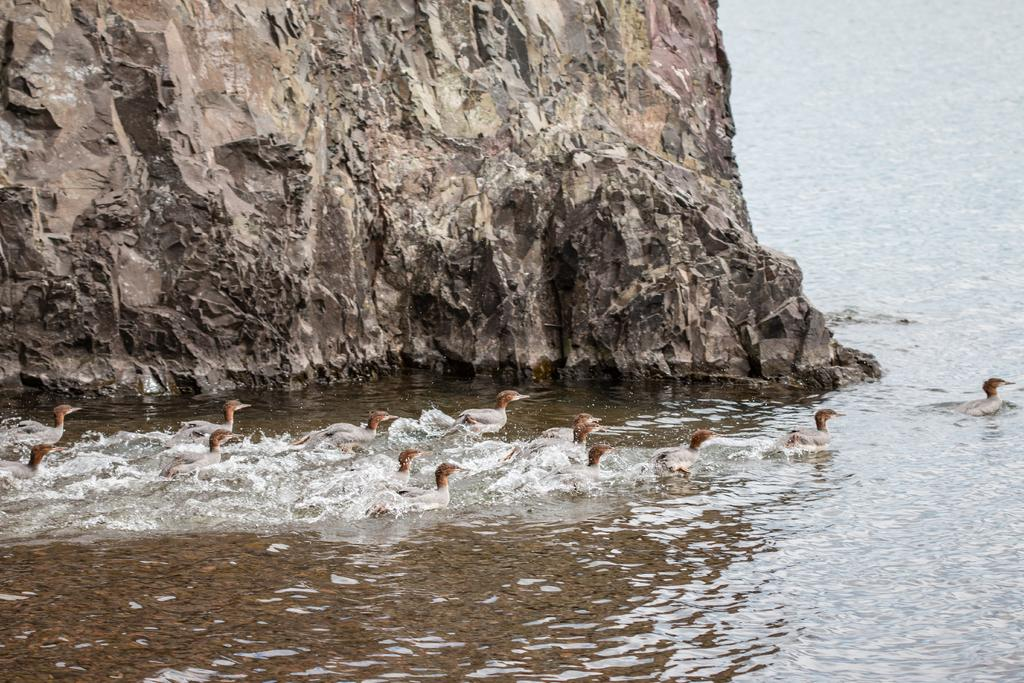What type of animals can be seen in the image? Birds can be seen in the image. What is the primary element in which the birds are situated? The birds are situated in water. Is there any other object or feature in the water? Yes, there is a rock in the water in the image. What type of judge can be seen in the image? There is no judge present in the image; it features birds in water with a rock. Can you provide a list of the birds' favorite activities in the image? There is no information provided about the birds' favorite activities, so it is not possible to create a list. 